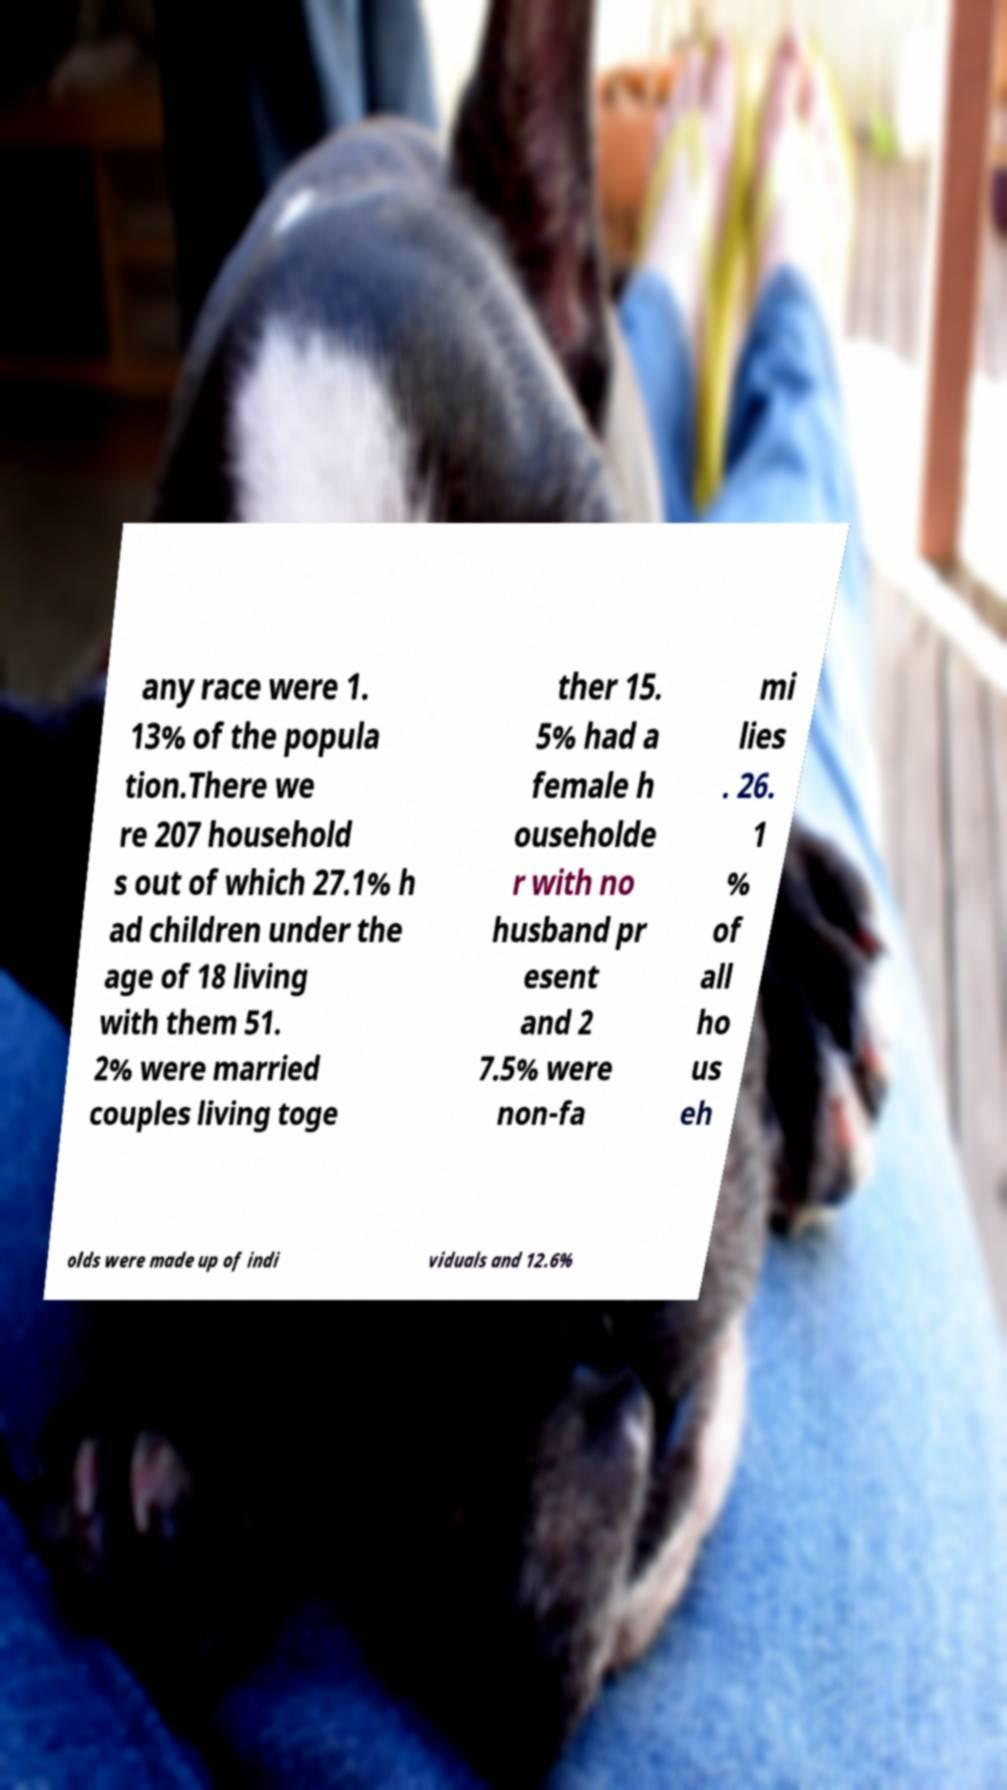Please identify and transcribe the text found in this image. any race were 1. 13% of the popula tion.There we re 207 household s out of which 27.1% h ad children under the age of 18 living with them 51. 2% were married couples living toge ther 15. 5% had a female h ouseholde r with no husband pr esent and 2 7.5% were non-fa mi lies . 26. 1 % of all ho us eh olds were made up of indi viduals and 12.6% 